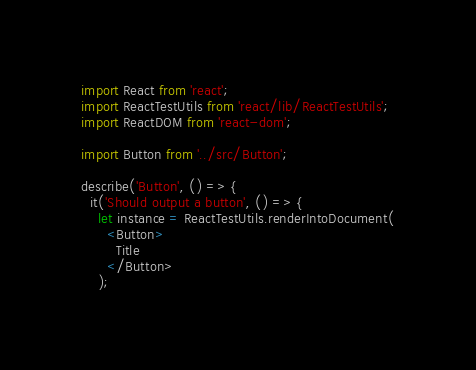<code> <loc_0><loc_0><loc_500><loc_500><_JavaScript_>import React from 'react';
import ReactTestUtils from 'react/lib/ReactTestUtils';
import ReactDOM from 'react-dom';

import Button from '../src/Button';

describe('Button', () => {
  it('Should output a button', () => {
    let instance = ReactTestUtils.renderIntoDocument(
      <Button>
        Title
      </Button>
    );</code> 